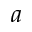<formula> <loc_0><loc_0><loc_500><loc_500>a</formula> 